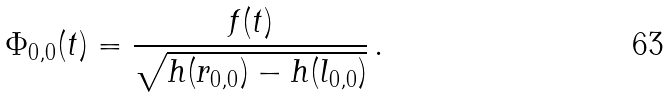<formula> <loc_0><loc_0><loc_500><loc_500>\Phi _ { 0 , 0 } ( t ) = \frac { f ( t ) } { \sqrt { h ( r _ { 0 , 0 } ) - h ( l _ { 0 , 0 } ) } } \, .</formula> 